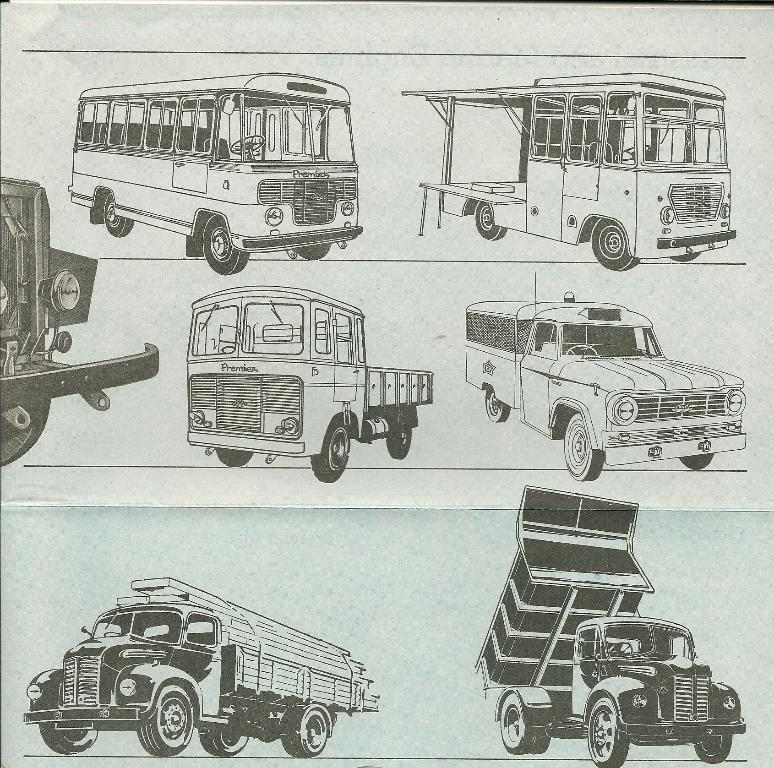What type of drawings are present in the image? The image contains drawings of vehicles. Can you name some of the vehicles depicted in the drawings? The vehicles include a bus, a lorry, and a truck. What type of writing can be seen on the side of the bus in the image? There is no writing visible on the side of the bus in the image, as it is a drawing and not a photograph. What type of growth can be observed on the truck in the image? There is no growth present on the truck in the image, as it is a drawing and not a photograph of a real truck. 